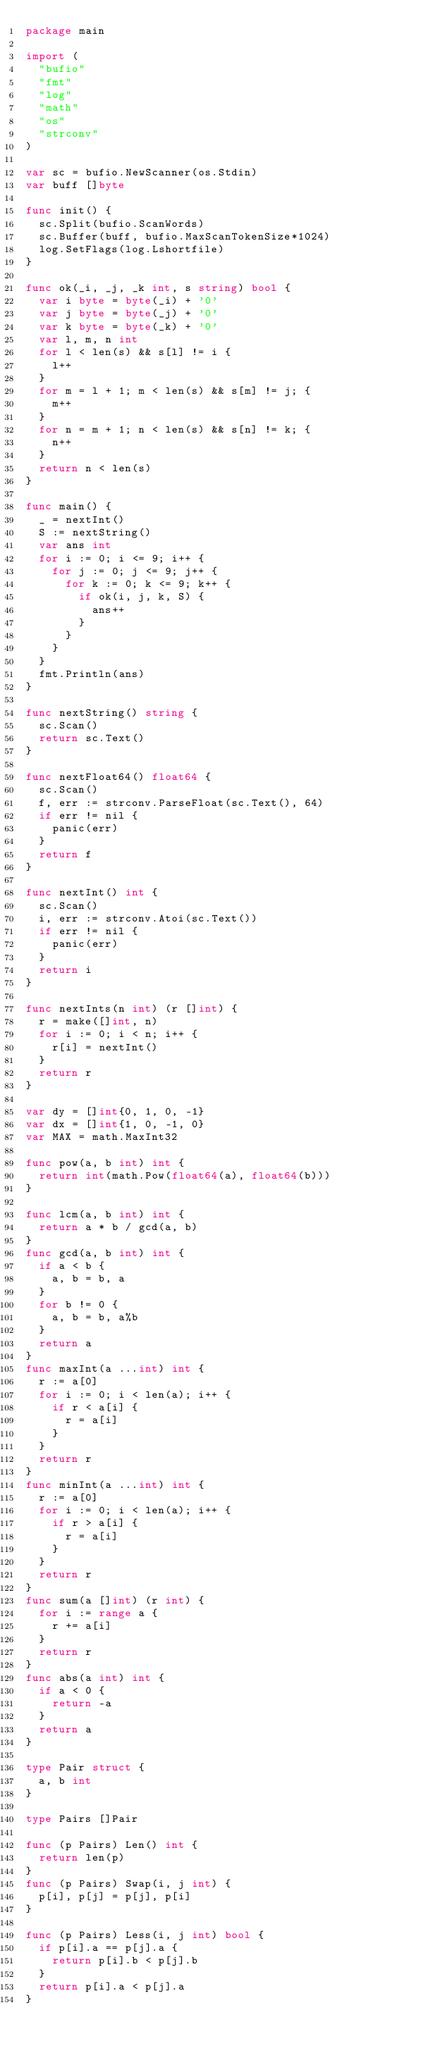Convert code to text. <code><loc_0><loc_0><loc_500><loc_500><_Go_>package main

import (
	"bufio"
	"fmt"
	"log"
	"math"
	"os"
	"strconv"
)

var sc = bufio.NewScanner(os.Stdin)
var buff []byte

func init() {
	sc.Split(bufio.ScanWords)
	sc.Buffer(buff, bufio.MaxScanTokenSize*1024)
	log.SetFlags(log.Lshortfile)
}

func ok(_i, _j, _k int, s string) bool {
	var i byte = byte(_i) + '0'
	var j byte = byte(_j) + '0'
	var k byte = byte(_k) + '0'
	var l, m, n int
	for l < len(s) && s[l] != i {
		l++
	}
	for m = l + 1; m < len(s) && s[m] != j; {
		m++
	}
	for n = m + 1; n < len(s) && s[n] != k; {
		n++
	}
	return n < len(s)
}

func main() {
	_ = nextInt()
	S := nextString()
	var ans int
	for i := 0; i <= 9; i++ {
		for j := 0; j <= 9; j++ {
			for k := 0; k <= 9; k++ {
				if ok(i, j, k, S) {
					ans++
				}
			}
		}
	}
	fmt.Println(ans)
}

func nextString() string {
	sc.Scan()
	return sc.Text()
}

func nextFloat64() float64 {
	sc.Scan()
	f, err := strconv.ParseFloat(sc.Text(), 64)
	if err != nil {
		panic(err)
	}
	return f
}

func nextInt() int {
	sc.Scan()
	i, err := strconv.Atoi(sc.Text())
	if err != nil {
		panic(err)
	}
	return i
}

func nextInts(n int) (r []int) {
	r = make([]int, n)
	for i := 0; i < n; i++ {
		r[i] = nextInt()
	}
	return r
}

var dy = []int{0, 1, 0, -1}
var dx = []int{1, 0, -1, 0}
var MAX = math.MaxInt32

func pow(a, b int) int {
	return int(math.Pow(float64(a), float64(b)))
}

func lcm(a, b int) int {
	return a * b / gcd(a, b)
}
func gcd(a, b int) int {
	if a < b {
		a, b = b, a
	}
	for b != 0 {
		a, b = b, a%b
	}
	return a
}
func maxInt(a ...int) int {
	r := a[0]
	for i := 0; i < len(a); i++ {
		if r < a[i] {
			r = a[i]
		}
	}
	return r
}
func minInt(a ...int) int {
	r := a[0]
	for i := 0; i < len(a); i++ {
		if r > a[i] {
			r = a[i]
		}
	}
	return r
}
func sum(a []int) (r int) {
	for i := range a {
		r += a[i]
	}
	return r
}
func abs(a int) int {
	if a < 0 {
		return -a
	}
	return a
}

type Pair struct {
	a, b int
}

type Pairs []Pair

func (p Pairs) Len() int {
	return len(p)
}
func (p Pairs) Swap(i, j int) {
	p[i], p[j] = p[j], p[i]
}

func (p Pairs) Less(i, j int) bool {
	if p[i].a == p[j].a {
		return p[i].b < p[j].b
	}
	return p[i].a < p[j].a
}
</code> 